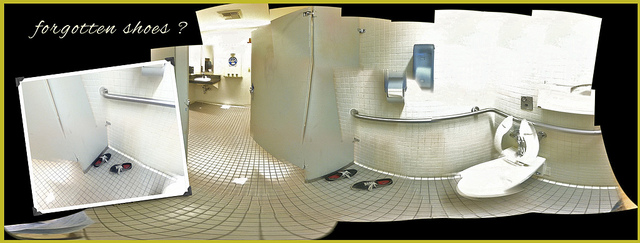Please transcribe the text in this image. forgotten shoes 